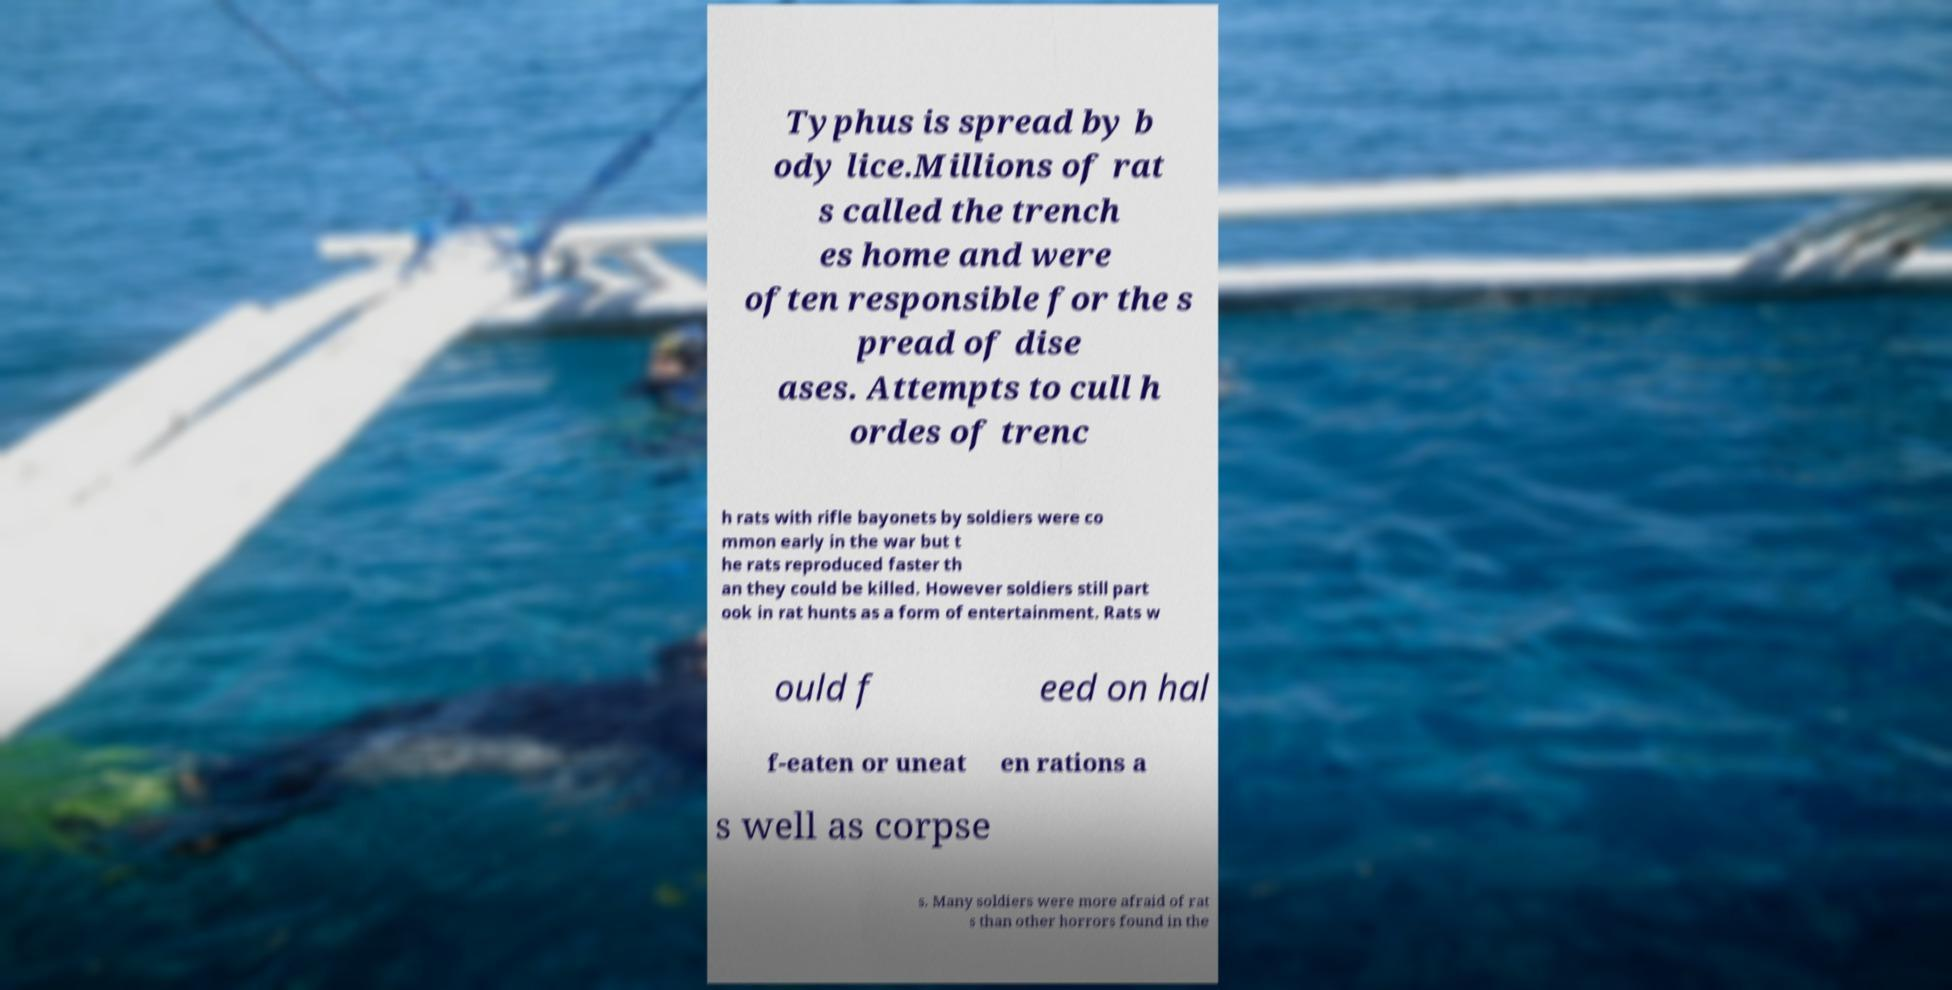Can you accurately transcribe the text from the provided image for me? Typhus is spread by b ody lice.Millions of rat s called the trench es home and were often responsible for the s pread of dise ases. Attempts to cull h ordes of trenc h rats with rifle bayonets by soldiers were co mmon early in the war but t he rats reproduced faster th an they could be killed. However soldiers still part ook in rat hunts as a form of entertainment. Rats w ould f eed on hal f-eaten or uneat en rations a s well as corpse s. Many soldiers were more afraid of rat s than other horrors found in the 